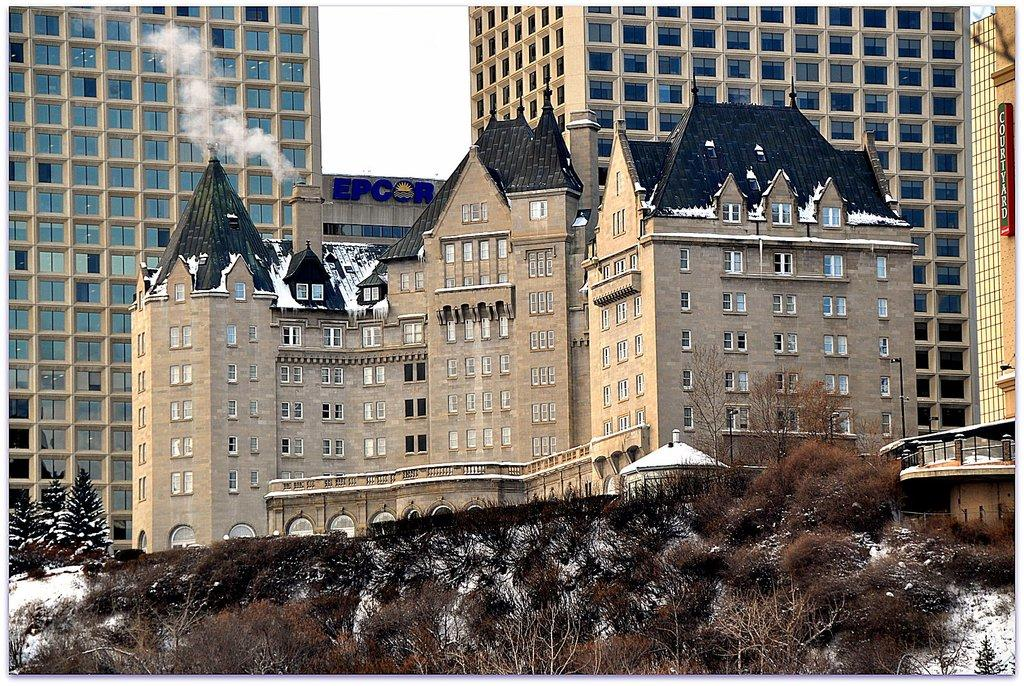What type of vegetation can be seen in the image? There are trees and plants in the image. What type of structures are present in the image? There are buildings in the image. What is the weather like in the image? There is snow in the image, indicating a cold or wintery environment. What are the name boards used for in the image? The name boards are likely used for identification or direction purposes. What is the source of the smoke in the image? The source of the smoke is not specified in the image, but it could be from a chimney, fire, or other source. What is visible at the top of the image? The sky is visible at the top of the image. How many kittens are playing with the wood and box in the image? There are no kittens, wood, or box present in the image. 